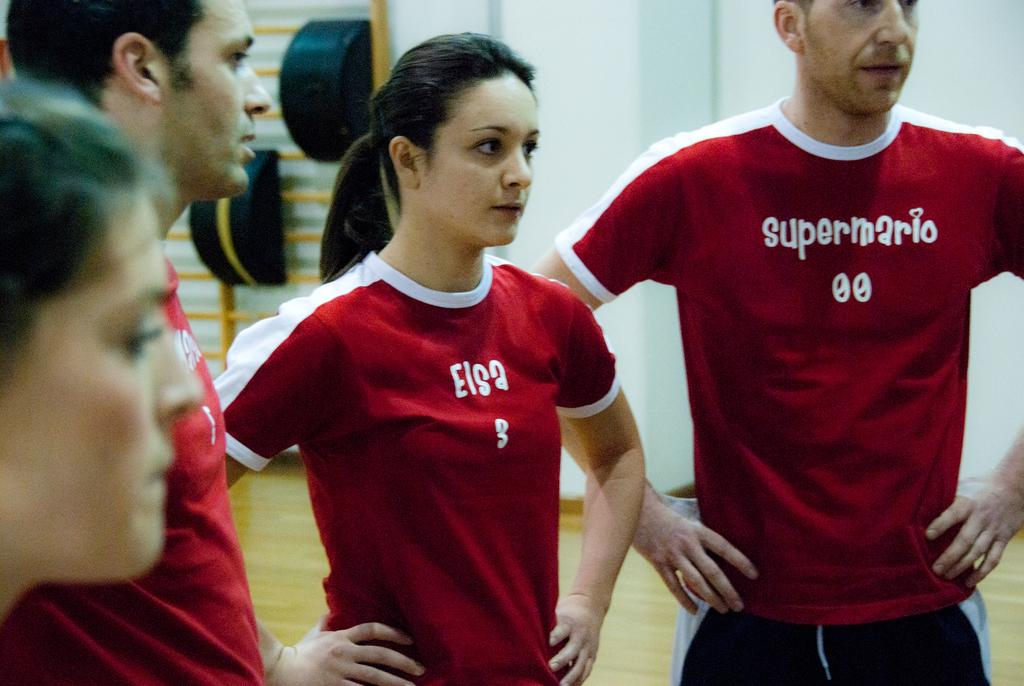<image>
Summarize the visual content of the image. a girl wearing a red shirt that says 'elsa 3' 